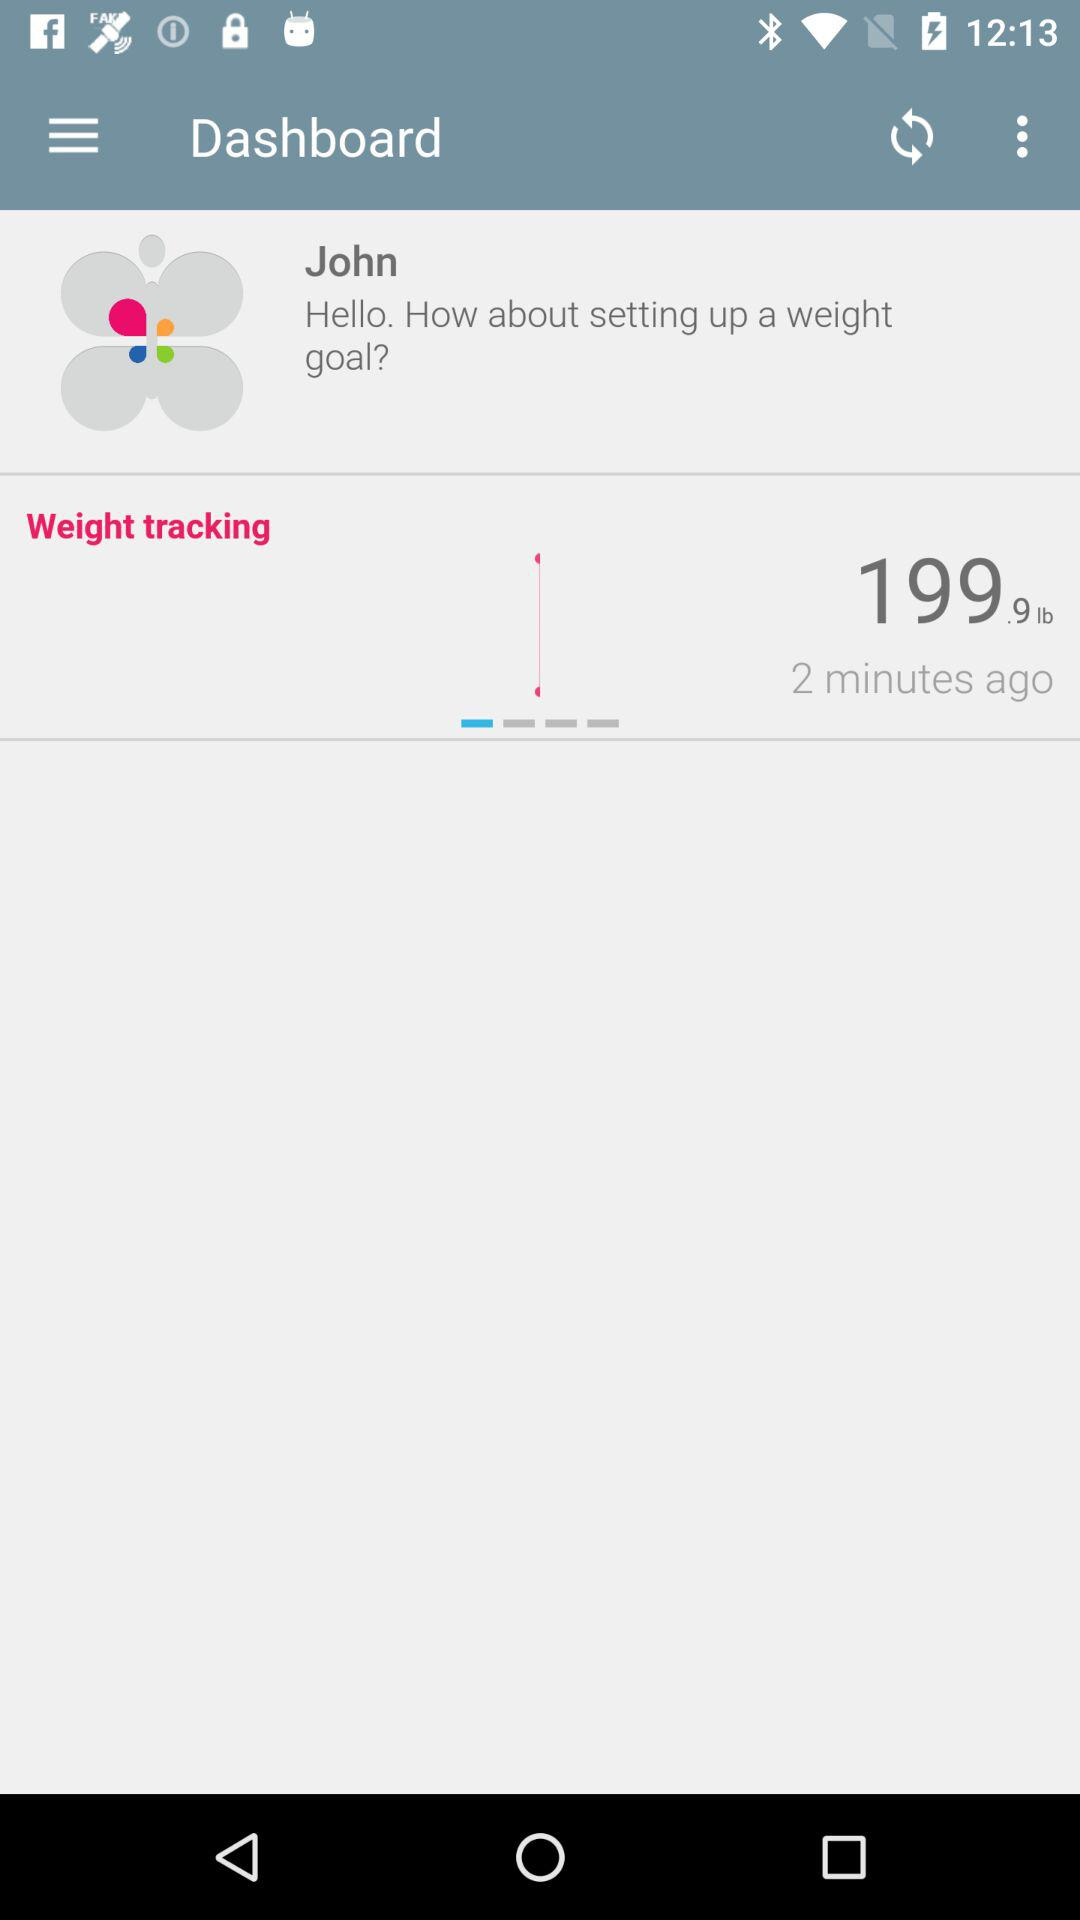What is the user name? The user name is John. 